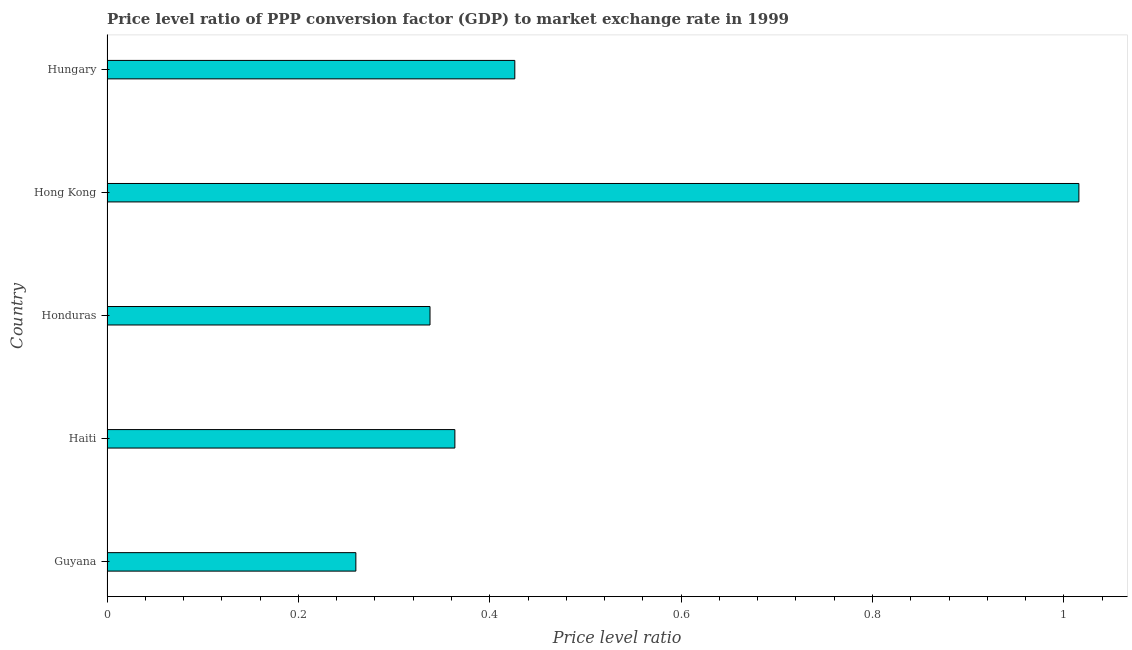Does the graph contain any zero values?
Provide a succinct answer. No. Does the graph contain grids?
Offer a terse response. No. What is the title of the graph?
Offer a very short reply. Price level ratio of PPP conversion factor (GDP) to market exchange rate in 1999. What is the label or title of the X-axis?
Ensure brevity in your answer.  Price level ratio. What is the price level ratio in Guyana?
Provide a short and direct response. 0.26. Across all countries, what is the maximum price level ratio?
Make the answer very short. 1.02. Across all countries, what is the minimum price level ratio?
Provide a succinct answer. 0.26. In which country was the price level ratio maximum?
Your answer should be compact. Hong Kong. In which country was the price level ratio minimum?
Your response must be concise. Guyana. What is the sum of the price level ratio?
Your answer should be compact. 2.4. What is the difference between the price level ratio in Haiti and Hong Kong?
Offer a terse response. -0.65. What is the average price level ratio per country?
Make the answer very short. 0.48. What is the median price level ratio?
Provide a succinct answer. 0.36. What is the ratio of the price level ratio in Guyana to that in Haiti?
Offer a terse response. 0.71. Is the price level ratio in Honduras less than that in Hungary?
Offer a terse response. Yes. What is the difference between the highest and the second highest price level ratio?
Your answer should be very brief. 0.59. Is the sum of the price level ratio in Guyana and Hungary greater than the maximum price level ratio across all countries?
Provide a succinct answer. No. What is the difference between the highest and the lowest price level ratio?
Your response must be concise. 0.76. How many bars are there?
Make the answer very short. 5. Are all the bars in the graph horizontal?
Provide a short and direct response. Yes. How many countries are there in the graph?
Offer a terse response. 5. What is the difference between two consecutive major ticks on the X-axis?
Your answer should be very brief. 0.2. What is the Price level ratio in Guyana?
Provide a short and direct response. 0.26. What is the Price level ratio of Haiti?
Provide a short and direct response. 0.36. What is the Price level ratio in Honduras?
Ensure brevity in your answer.  0.34. What is the Price level ratio in Hong Kong?
Offer a terse response. 1.02. What is the Price level ratio in Hungary?
Offer a very short reply. 0.43. What is the difference between the Price level ratio in Guyana and Haiti?
Make the answer very short. -0.1. What is the difference between the Price level ratio in Guyana and Honduras?
Offer a terse response. -0.08. What is the difference between the Price level ratio in Guyana and Hong Kong?
Make the answer very short. -0.76. What is the difference between the Price level ratio in Guyana and Hungary?
Ensure brevity in your answer.  -0.17. What is the difference between the Price level ratio in Haiti and Honduras?
Keep it short and to the point. 0.03. What is the difference between the Price level ratio in Haiti and Hong Kong?
Offer a terse response. -0.65. What is the difference between the Price level ratio in Haiti and Hungary?
Ensure brevity in your answer.  -0.06. What is the difference between the Price level ratio in Honduras and Hong Kong?
Offer a terse response. -0.68. What is the difference between the Price level ratio in Honduras and Hungary?
Your answer should be very brief. -0.09. What is the difference between the Price level ratio in Hong Kong and Hungary?
Offer a terse response. 0.59. What is the ratio of the Price level ratio in Guyana to that in Haiti?
Keep it short and to the point. 0.71. What is the ratio of the Price level ratio in Guyana to that in Honduras?
Your answer should be very brief. 0.77. What is the ratio of the Price level ratio in Guyana to that in Hong Kong?
Ensure brevity in your answer.  0.26. What is the ratio of the Price level ratio in Guyana to that in Hungary?
Make the answer very short. 0.61. What is the ratio of the Price level ratio in Haiti to that in Honduras?
Offer a terse response. 1.08. What is the ratio of the Price level ratio in Haiti to that in Hong Kong?
Provide a short and direct response. 0.36. What is the ratio of the Price level ratio in Haiti to that in Hungary?
Offer a very short reply. 0.85. What is the ratio of the Price level ratio in Honduras to that in Hong Kong?
Keep it short and to the point. 0.33. What is the ratio of the Price level ratio in Honduras to that in Hungary?
Provide a succinct answer. 0.79. What is the ratio of the Price level ratio in Hong Kong to that in Hungary?
Offer a terse response. 2.38. 